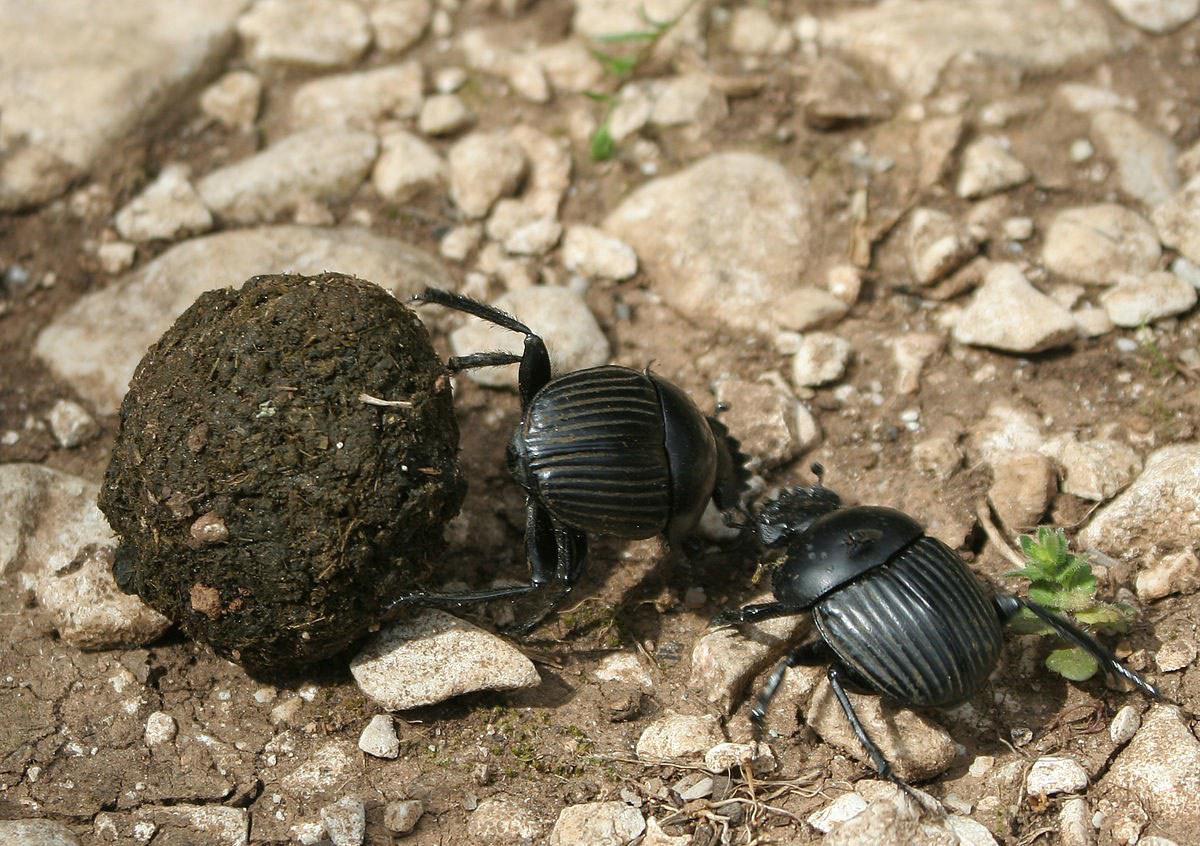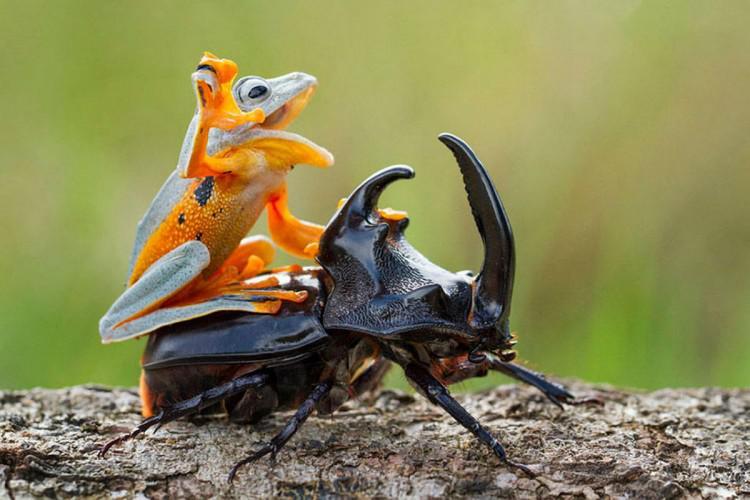The first image is the image on the left, the second image is the image on the right. Given the left and right images, does the statement "There are at least three beetles." hold true? Answer yes or no. Yes. 